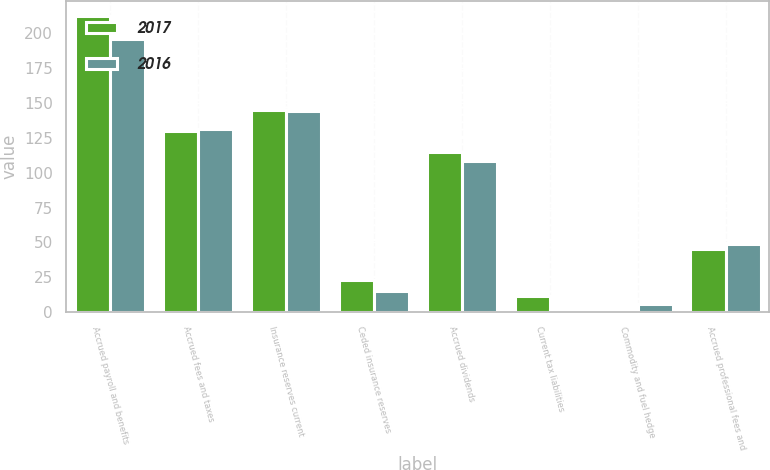Convert chart. <chart><loc_0><loc_0><loc_500><loc_500><stacked_bar_chart><ecel><fcel>Accrued payroll and benefits<fcel>Accrued fees and taxes<fcel>Insurance reserves current<fcel>Ceded insurance reserves<fcel>Accrued dividends<fcel>Current tax liabilities<fcel>Commodity and fuel hedge<fcel>Accrued professional fees and<nl><fcel>2017<fcel>212.2<fcel>129.7<fcel>144.8<fcel>23.1<fcel>114.4<fcel>11.7<fcel>0.3<fcel>45.1<nl><fcel>2016<fcel>195.4<fcel>131.2<fcel>143.9<fcel>15<fcel>108.6<fcel>1.4<fcel>5.9<fcel>49.2<nl></chart> 